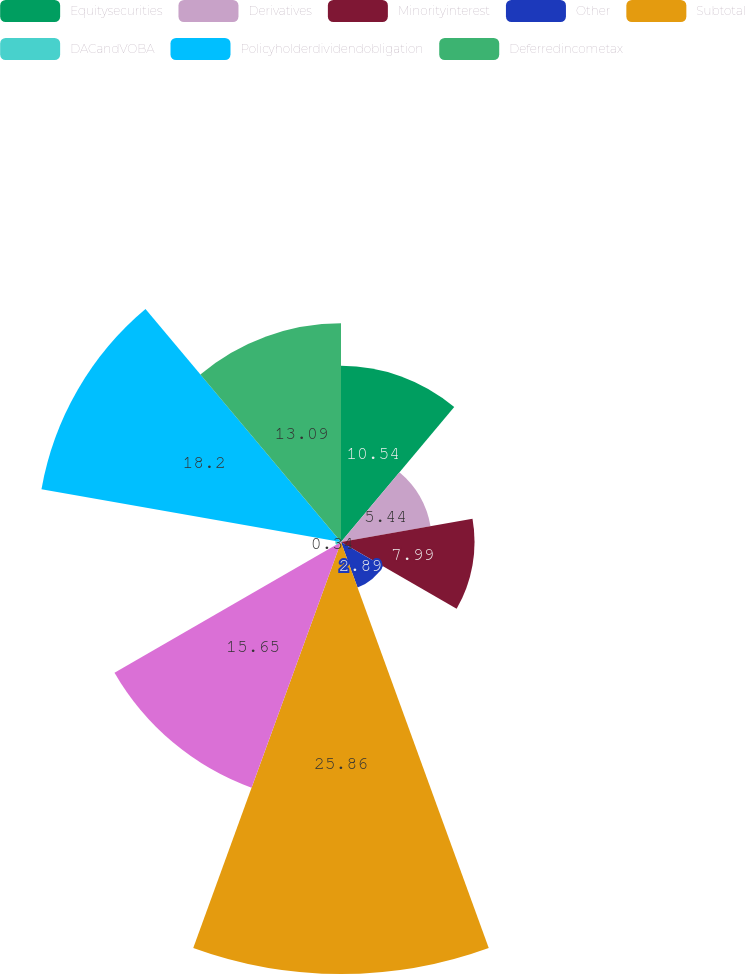<chart> <loc_0><loc_0><loc_500><loc_500><pie_chart><fcel>Equitysecurities<fcel>Derivatives<fcel>Minorityinterest<fcel>Other<fcel>Subtotal<fcel>Unnamed: 5<fcel>DACandVOBA<fcel>Policyholderdividendobligation<fcel>Deferredincometax<nl><fcel>10.54%<fcel>5.44%<fcel>7.99%<fcel>2.89%<fcel>25.85%<fcel>15.65%<fcel>0.34%<fcel>18.2%<fcel>13.09%<nl></chart> 